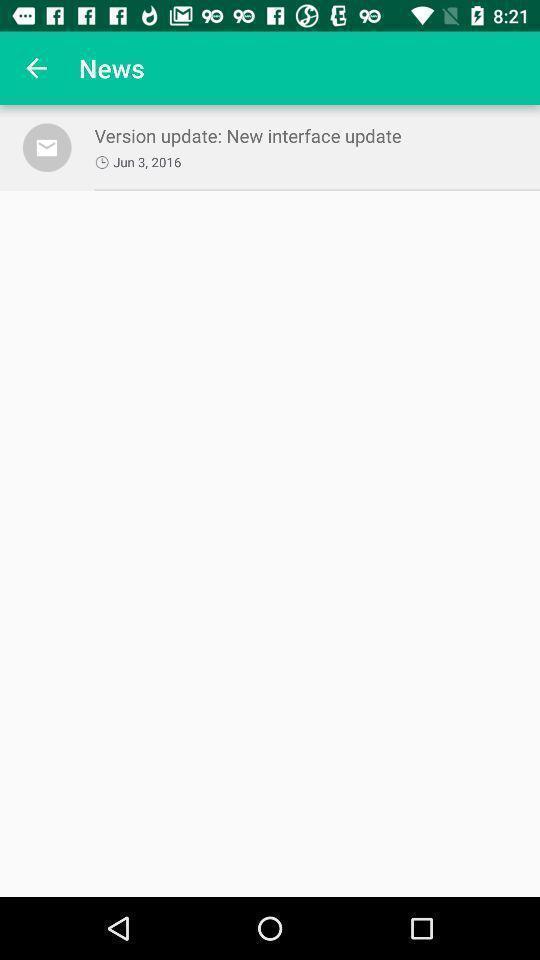Describe the content in this image. Screen shows update on a news app. 